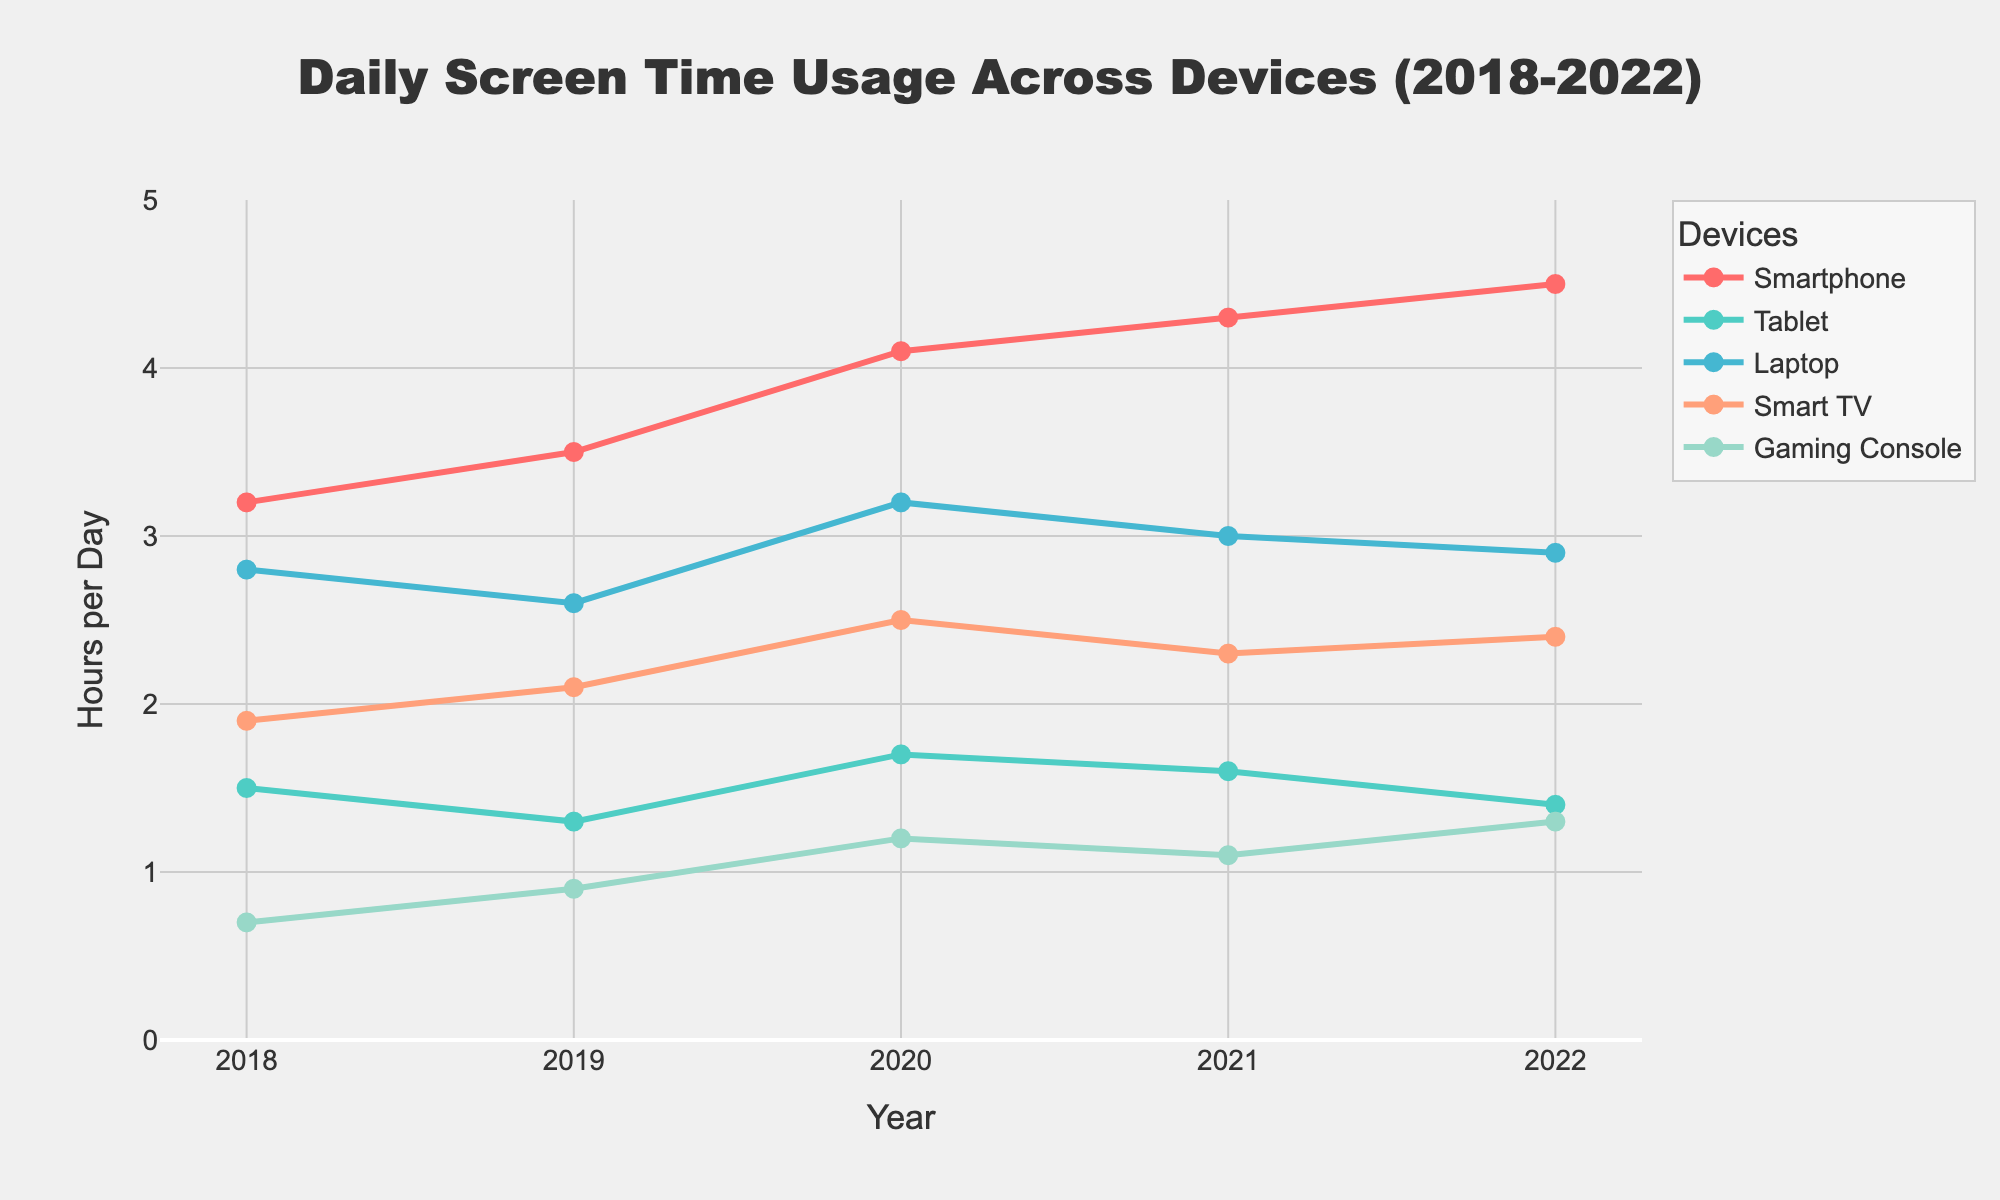What is the average daily screen time of the Laptop over the 5-year period? First, add up the daily screen time values for the Laptop over the 5 years: 2.8 + 2.6 + 3.2 + 3.0 + 2.9 = 14.5 hours. Then, divide by the number of years (5) to get the average: 14.5 / 5 = 2.9 hours.
Answer: 2.9 hours Which device had the highest increase in daily screen time from 2018 to 2022? The increase for each device from 2018 to 2022 is calculated: Smartphone (4.5 - 3.2 = 1.3), Tablet (1.4 - 1.5 = -0.1), Laptop (2.9 - 2.8 = 0.1), Smart TV (2.4 - 1.9 = 0.5), Gaming Console (1.3 - 0.7 = 0.6). The Smartphone had the highest increase.
Answer: Smartphone For which year was the daily screen time of Tablets the lowest? Look at the Tablet screen time values for each year: 2018 (1.5), 2019 (1.3), 2020 (1.7), 2021 (1.6), 2022 (1.4). The lowest value is in 2019.
Answer: 2019 By how much did the daily screen time of Smart TVs change from 2020 to 2021? The Smart TV screen time in 2020 was 2.5 hours and in 2021 it was 2.3 hours. The change is calculated as 2.3 - 2.5 = -0.2 hours, indicating a decrease.
Answer: -0.2 hours Which device had more hours of usage per day in 2022: Gaming Consoles or Tablets? In 2022, the daily screen time for Gaming Consoles is 1.3 hours and for Tablets is 1.4 hours. Comparing these values, Tablets had more usage.
Answer: Tablets In which year did Smartphones first exceed 4 hours of daily screen time? Look through the data to see when Smartphones exceed 4 hours: 2018 (3.2), 2019 (3.5), 2020 (4.1), 2021 (4.3), 2022 (4.5). The first year Smartphones exceeded 4 hours is 2020.
Answer: 2020 How does the daily screen time for Laptops in 2021 compare to that in 2020? The daily screen time for Laptops in 2020 is 3.2 hours and in 2021 it is 3.0 hours. Comparing these values, 3.0 is less than 3.2.
Answer: Less Between 2019 and 2021, did the Smart TV daily screen time increase or decrease and by how much? The Smart TV screen time in 2019 was 2.1 hours and in 2021 it was 2.3 hours. The change is calculated as 2.3 - 2.1 = 0.2 hours, indicating an increase.
Answer: Increase by 0.2 hours 